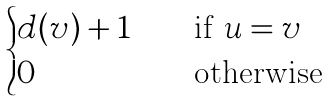Convert formula to latex. <formula><loc_0><loc_0><loc_500><loc_500>\begin{cases} d ( v ) + 1 & \quad \text {if $u = v$} \\ 0 & \quad \text {otherwise} \\ \end{cases}</formula> 